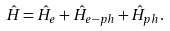Convert formula to latex. <formula><loc_0><loc_0><loc_500><loc_500>\hat { H } = \hat { H } _ { e } + \hat { H } _ { e - p h } + \hat { H } _ { p h } .</formula> 